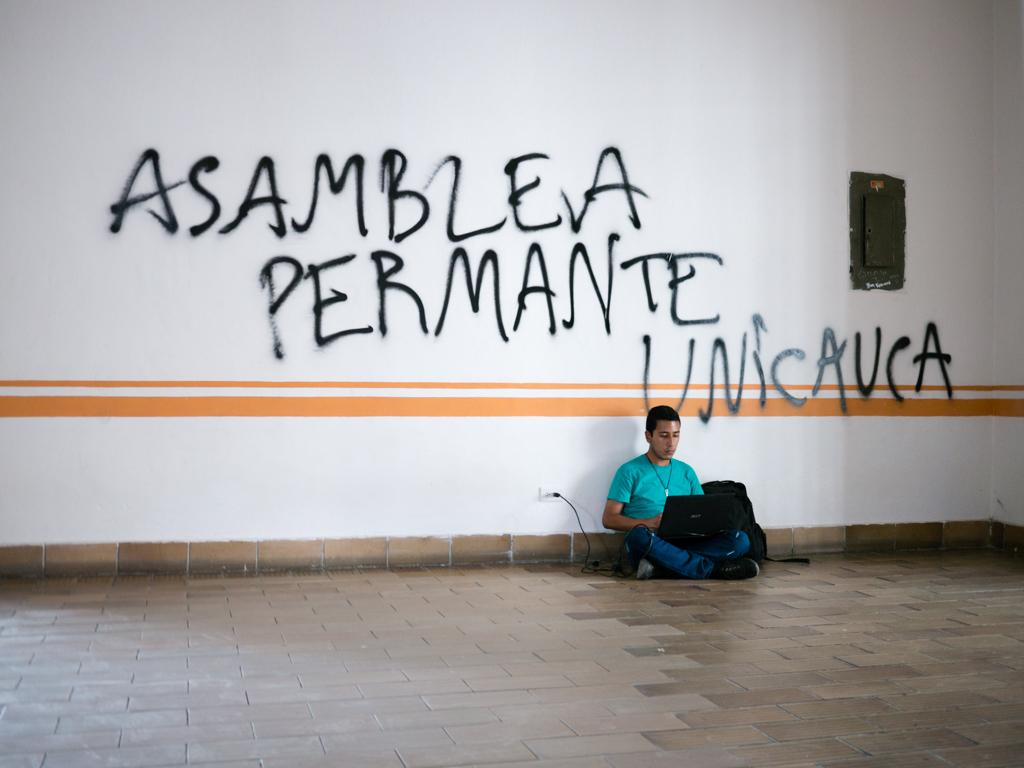Who is in the image? There is a boy in the image. What is the boy doing in the image? The boy is sitting on the floor and operating a laptop. Where is the laptop located in the image? The laptop is on the right side of the image. What else can be seen on the right side of the image? There is a box on the wall on the right side of the image. What type of sweater is the boy wearing in the image? The image does not show the boy wearing a sweater, so it cannot be determined from the image. How many times does the boy push the laptop in the image? The image does not show the boy pushing the laptop, so it cannot be determined from the image. 